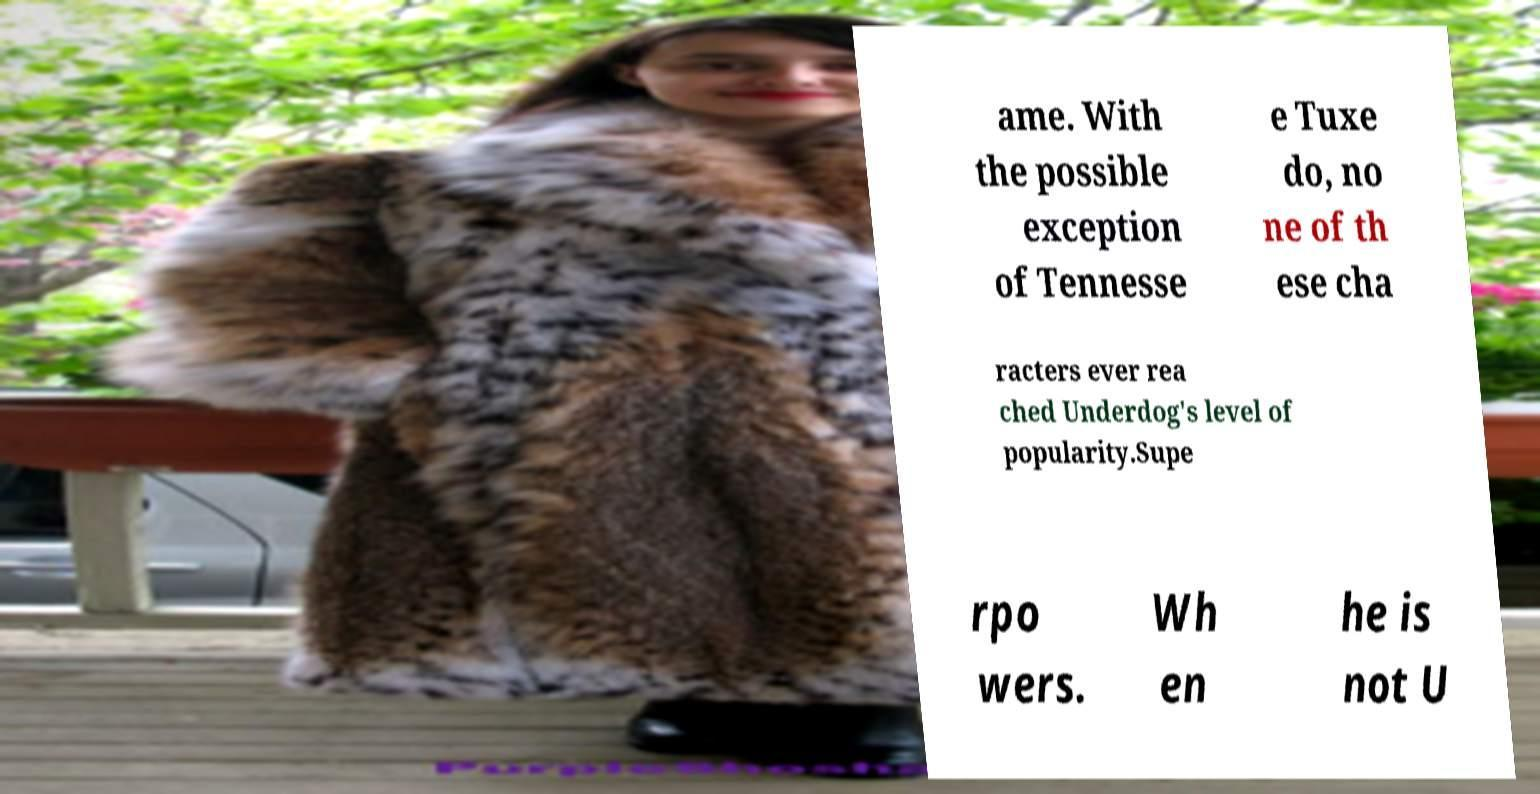Could you assist in decoding the text presented in this image and type it out clearly? ame. With the possible exception of Tennesse e Tuxe do, no ne of th ese cha racters ever rea ched Underdog's level of popularity.Supe rpo wers. Wh en he is not U 